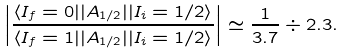Convert formula to latex. <formula><loc_0><loc_0><loc_500><loc_500>\left | \frac { \langle I _ { f } = 0 | | A _ { 1 / 2 } | | I _ { i } = 1 / 2 \rangle } { \langle I _ { f } = 1 | | A _ { 1 / 2 } | | I _ { i } = 1 / 2 \rangle } \right | \simeq \frac { 1 } { 3 . 7 } \div 2 . 3 .</formula> 